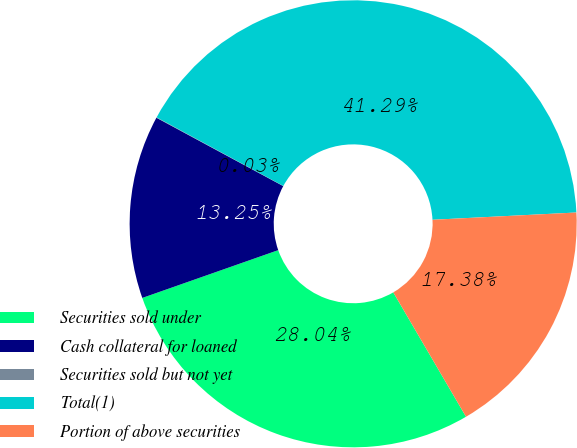Convert chart. <chart><loc_0><loc_0><loc_500><loc_500><pie_chart><fcel>Securities sold under<fcel>Cash collateral for loaned<fcel>Securities sold but not yet<fcel>Total(1)<fcel>Portion of above securities<nl><fcel>28.04%<fcel>13.25%<fcel>0.03%<fcel>41.29%<fcel>17.38%<nl></chart> 